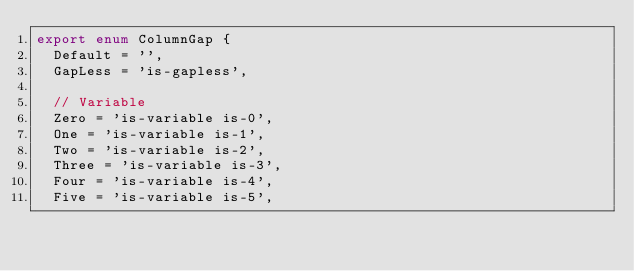<code> <loc_0><loc_0><loc_500><loc_500><_TypeScript_>export enum ColumnGap {
  Default = '',
  GapLess = 'is-gapless',

  // Variable
  Zero = 'is-variable is-0',
  One = 'is-variable is-1',
  Two = 'is-variable is-2',
  Three = 'is-variable is-3',
  Four = 'is-variable is-4',
  Five = 'is-variable is-5',</code> 